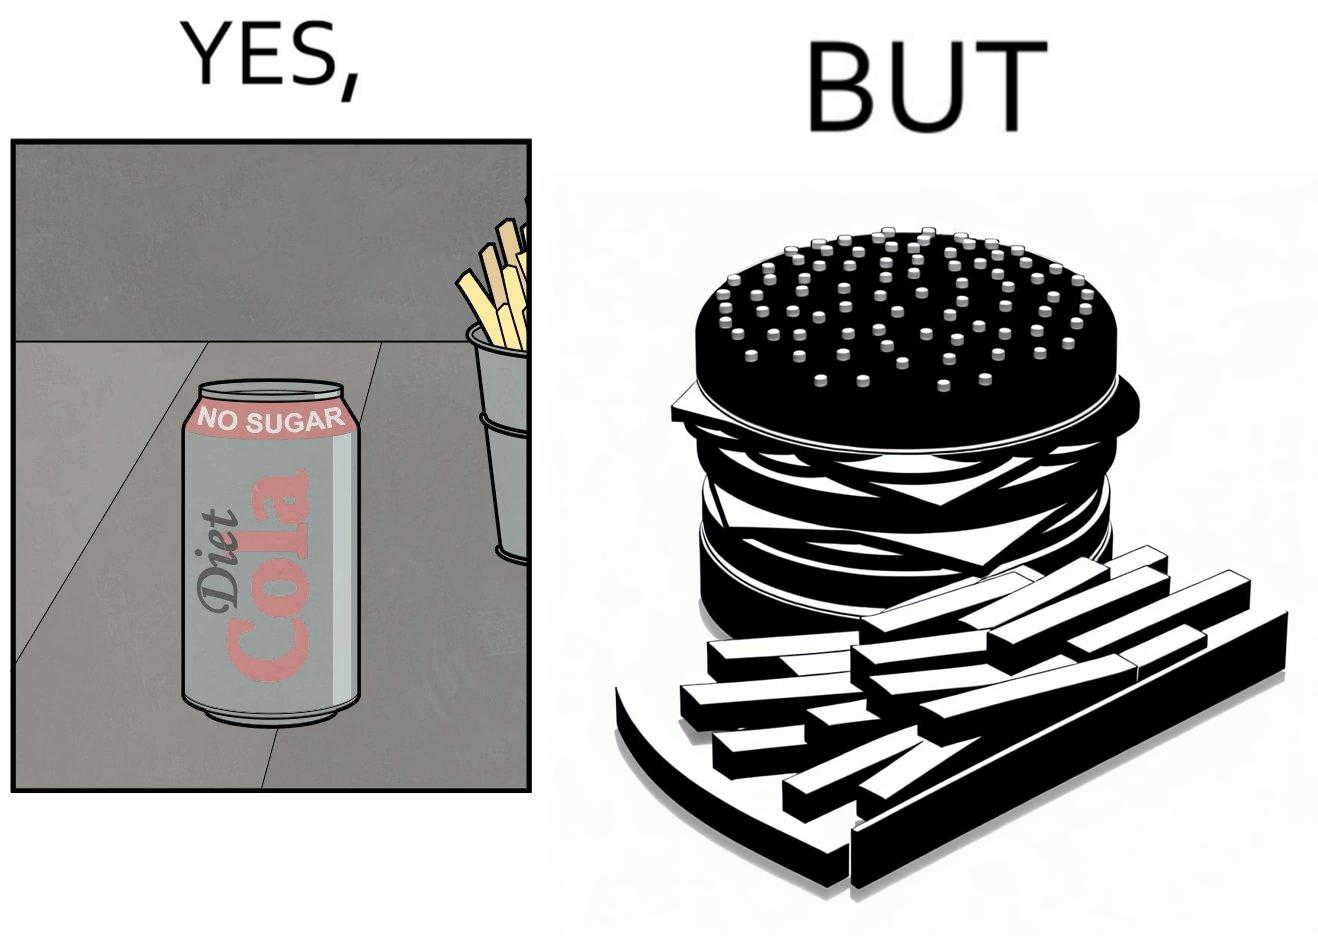Describe the satirical element in this image. The image is ironic, because on one hand the person is consuming diet cola suggesting low on sugar as per label meaning the person is health-conscious but on the other hand the same one is having huge size burger with french fries which suggests the person to be health-ignorant 